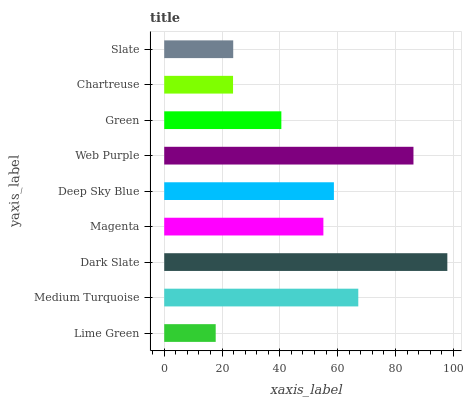Is Lime Green the minimum?
Answer yes or no. Yes. Is Dark Slate the maximum?
Answer yes or no. Yes. Is Medium Turquoise the minimum?
Answer yes or no. No. Is Medium Turquoise the maximum?
Answer yes or no. No. Is Medium Turquoise greater than Lime Green?
Answer yes or no. Yes. Is Lime Green less than Medium Turquoise?
Answer yes or no. Yes. Is Lime Green greater than Medium Turquoise?
Answer yes or no. No. Is Medium Turquoise less than Lime Green?
Answer yes or no. No. Is Magenta the high median?
Answer yes or no. Yes. Is Magenta the low median?
Answer yes or no. Yes. Is Dark Slate the high median?
Answer yes or no. No. Is Web Purple the low median?
Answer yes or no. No. 